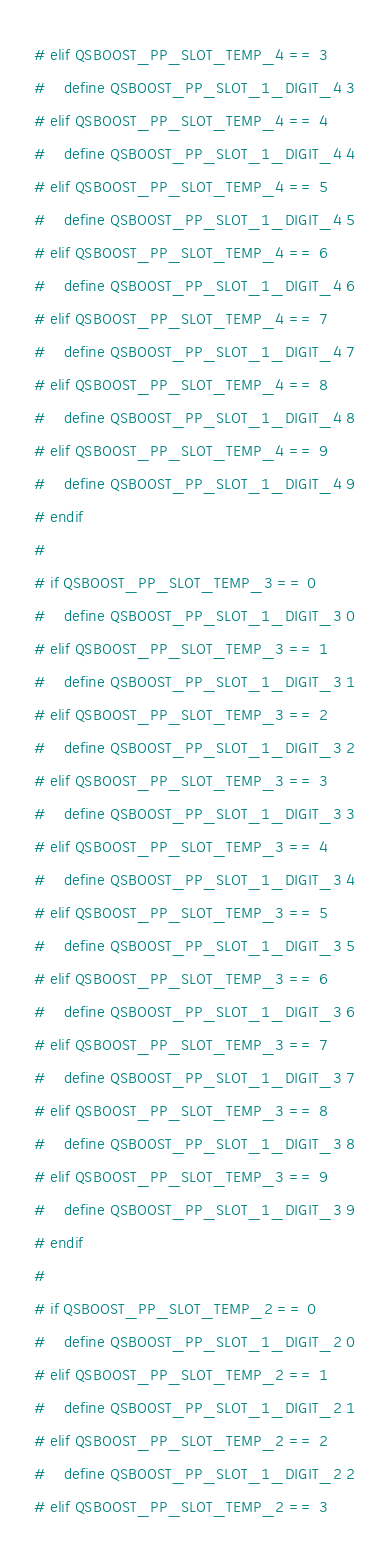Convert code to text. <code><loc_0><loc_0><loc_500><loc_500><_C++_># elif QSBOOST_PP_SLOT_TEMP_4 == 3
#    define QSBOOST_PP_SLOT_1_DIGIT_4 3
# elif QSBOOST_PP_SLOT_TEMP_4 == 4
#    define QSBOOST_PP_SLOT_1_DIGIT_4 4
# elif QSBOOST_PP_SLOT_TEMP_4 == 5
#    define QSBOOST_PP_SLOT_1_DIGIT_4 5
# elif QSBOOST_PP_SLOT_TEMP_4 == 6
#    define QSBOOST_PP_SLOT_1_DIGIT_4 6
# elif QSBOOST_PP_SLOT_TEMP_4 == 7
#    define QSBOOST_PP_SLOT_1_DIGIT_4 7
# elif QSBOOST_PP_SLOT_TEMP_4 == 8
#    define QSBOOST_PP_SLOT_1_DIGIT_4 8
# elif QSBOOST_PP_SLOT_TEMP_4 == 9
#    define QSBOOST_PP_SLOT_1_DIGIT_4 9
# endif
#
# if QSBOOST_PP_SLOT_TEMP_3 == 0
#    define QSBOOST_PP_SLOT_1_DIGIT_3 0
# elif QSBOOST_PP_SLOT_TEMP_3 == 1
#    define QSBOOST_PP_SLOT_1_DIGIT_3 1
# elif QSBOOST_PP_SLOT_TEMP_3 == 2
#    define QSBOOST_PP_SLOT_1_DIGIT_3 2
# elif QSBOOST_PP_SLOT_TEMP_3 == 3
#    define QSBOOST_PP_SLOT_1_DIGIT_3 3
# elif QSBOOST_PP_SLOT_TEMP_3 == 4
#    define QSBOOST_PP_SLOT_1_DIGIT_3 4
# elif QSBOOST_PP_SLOT_TEMP_3 == 5
#    define QSBOOST_PP_SLOT_1_DIGIT_3 5
# elif QSBOOST_PP_SLOT_TEMP_3 == 6
#    define QSBOOST_PP_SLOT_1_DIGIT_3 6
# elif QSBOOST_PP_SLOT_TEMP_3 == 7
#    define QSBOOST_PP_SLOT_1_DIGIT_3 7
# elif QSBOOST_PP_SLOT_TEMP_3 == 8
#    define QSBOOST_PP_SLOT_1_DIGIT_3 8
# elif QSBOOST_PP_SLOT_TEMP_3 == 9
#    define QSBOOST_PP_SLOT_1_DIGIT_3 9
# endif
#
# if QSBOOST_PP_SLOT_TEMP_2 == 0
#    define QSBOOST_PP_SLOT_1_DIGIT_2 0
# elif QSBOOST_PP_SLOT_TEMP_2 == 1
#    define QSBOOST_PP_SLOT_1_DIGIT_2 1
# elif QSBOOST_PP_SLOT_TEMP_2 == 2
#    define QSBOOST_PP_SLOT_1_DIGIT_2 2
# elif QSBOOST_PP_SLOT_TEMP_2 == 3</code> 